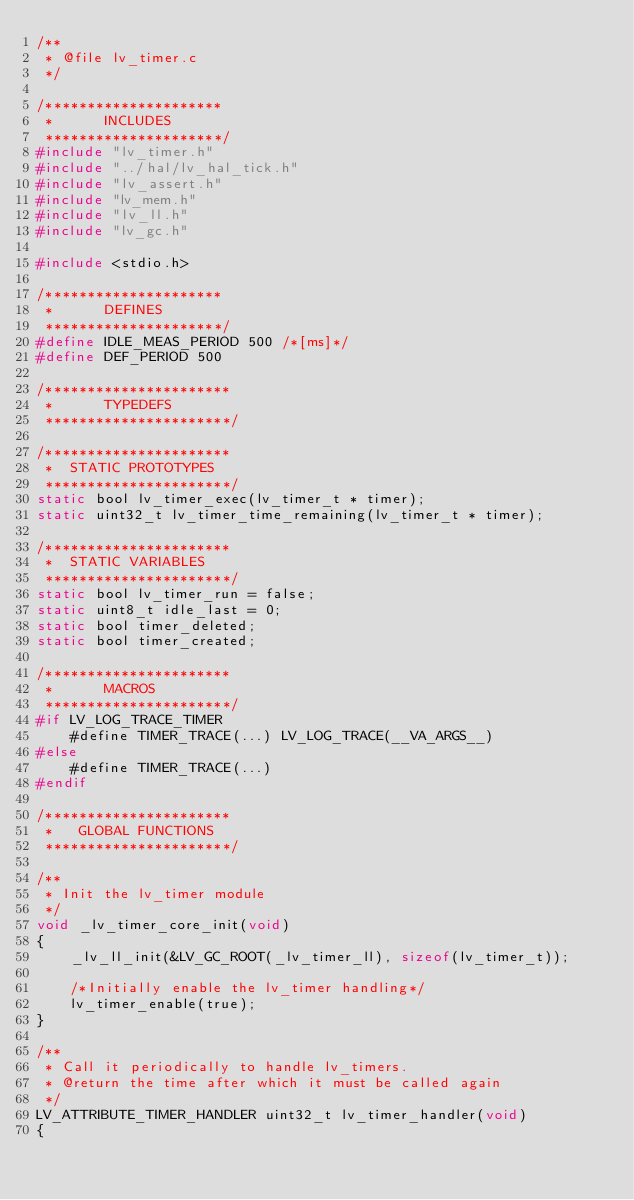Convert code to text. <code><loc_0><loc_0><loc_500><loc_500><_C_>/**
 * @file lv_timer.c
 */

/*********************
 *      INCLUDES
 *********************/
#include "lv_timer.h"
#include "../hal/lv_hal_tick.h"
#include "lv_assert.h"
#include "lv_mem.h"
#include "lv_ll.h"
#include "lv_gc.h"

#include <stdio.h>

/*********************
 *      DEFINES
 *********************/
#define IDLE_MEAS_PERIOD 500 /*[ms]*/
#define DEF_PERIOD 500

/**********************
 *      TYPEDEFS
 **********************/

/**********************
 *  STATIC PROTOTYPES
 **********************/
static bool lv_timer_exec(lv_timer_t * timer);
static uint32_t lv_timer_time_remaining(lv_timer_t * timer);

/**********************
 *  STATIC VARIABLES
 **********************/
static bool lv_timer_run = false;
static uint8_t idle_last = 0;
static bool timer_deleted;
static bool timer_created;

/**********************
 *      MACROS
 **********************/
#if LV_LOG_TRACE_TIMER
    #define TIMER_TRACE(...) LV_LOG_TRACE(__VA_ARGS__)
#else
    #define TIMER_TRACE(...)
#endif

/**********************
 *   GLOBAL FUNCTIONS
 **********************/

/**
 * Init the lv_timer module
 */
void _lv_timer_core_init(void)
{
    _lv_ll_init(&LV_GC_ROOT(_lv_timer_ll), sizeof(lv_timer_t));

    /*Initially enable the lv_timer handling*/
    lv_timer_enable(true);
}

/**
 * Call it periodically to handle lv_timers.
 * @return the time after which it must be called again
 */
LV_ATTRIBUTE_TIMER_HANDLER uint32_t lv_timer_handler(void)
{</code> 